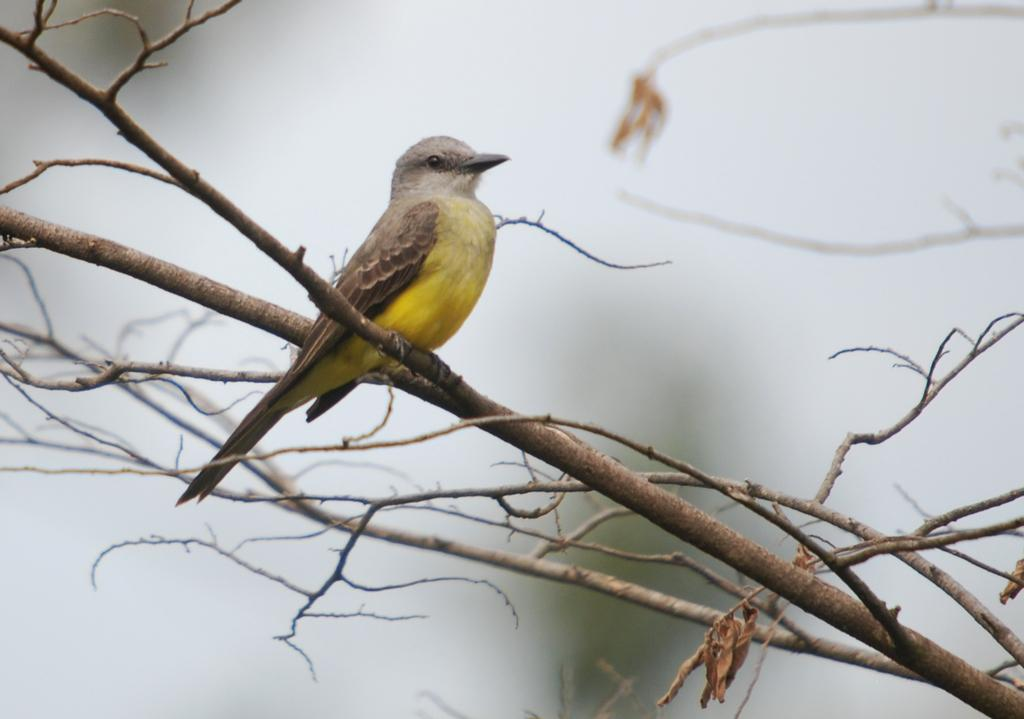What type of animal can be seen in the image? There is a bird in the image. Where is the bird located? The bird is standing on a tree branch. What can be seen in the background of the image? There is fog visible in the background of the image. What type of mark can be seen on the bird's wing in the image? There is no mark visible on the bird's wing in the image. Is there a rifle present in the image? No, there is no rifle present in the image. Can you hear the engine of a vehicle in the image? There is no sound or indication of an engine in the image. 